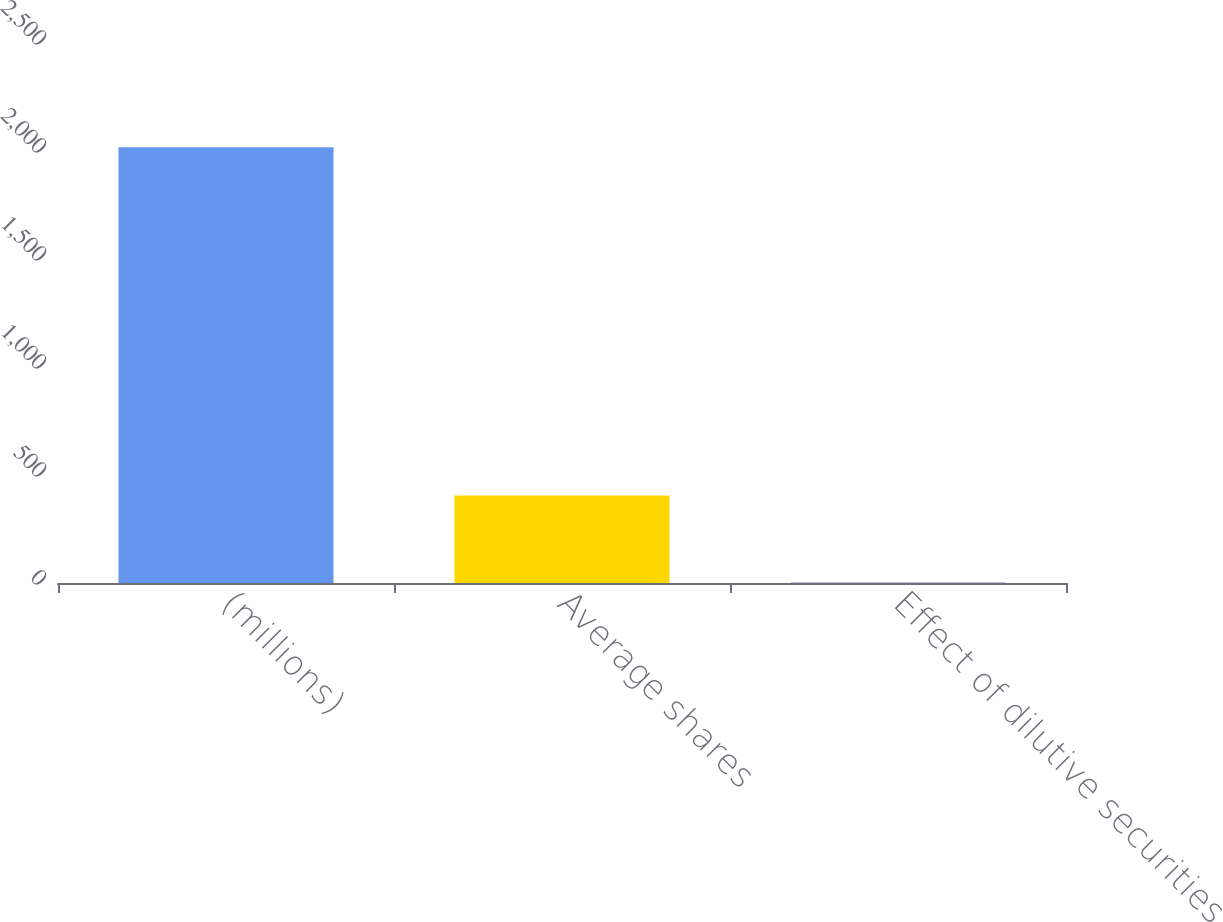Convert chart. <chart><loc_0><loc_0><loc_500><loc_500><bar_chart><fcel>(millions)<fcel>Average shares<fcel>Effect of dilutive securities<nl><fcel>2017<fcel>404.68<fcel>1.6<nl></chart> 